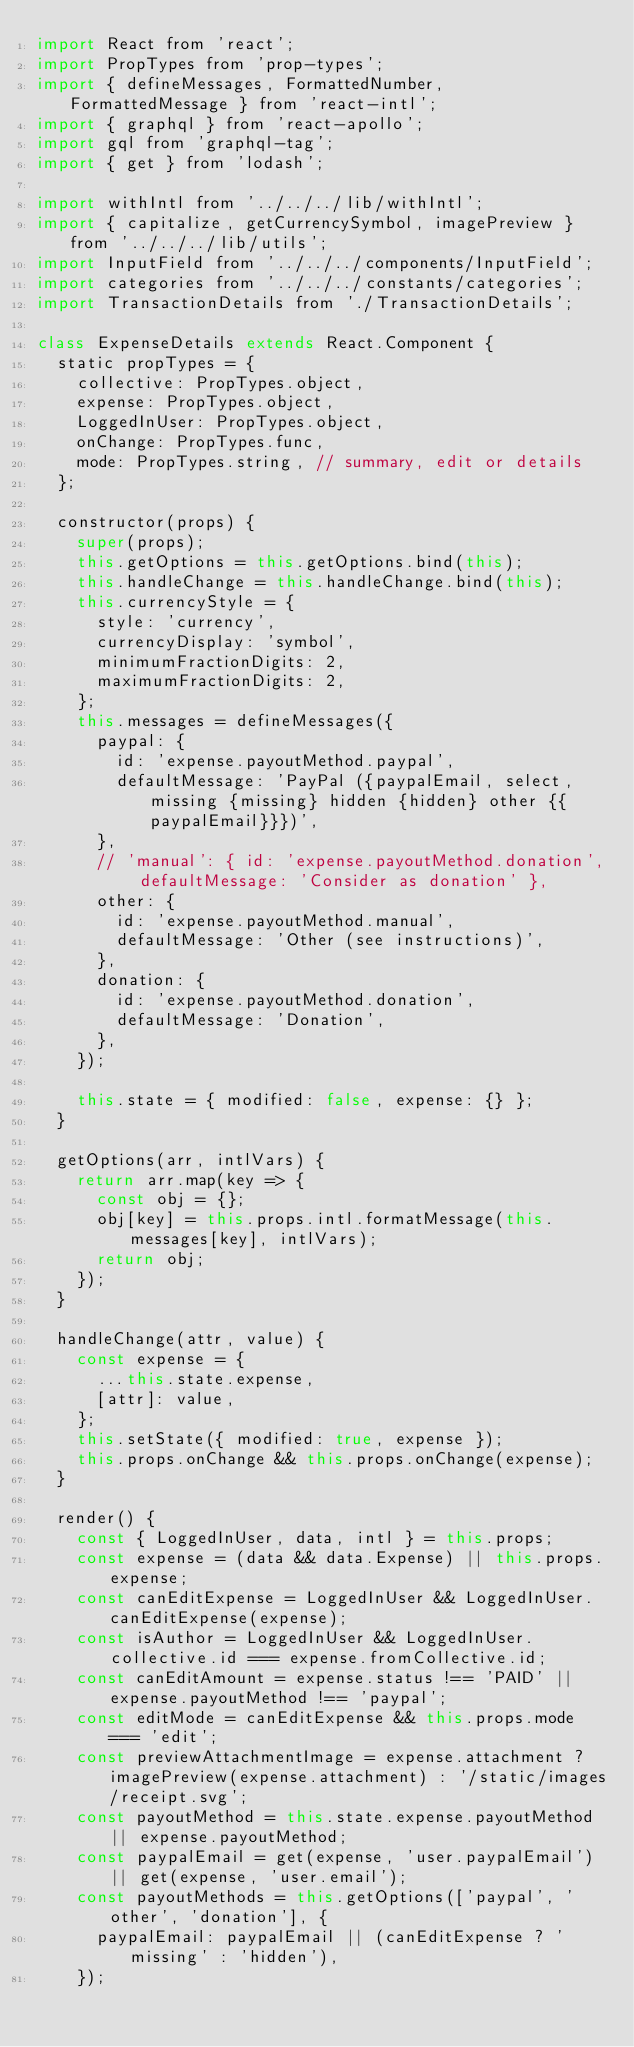<code> <loc_0><loc_0><loc_500><loc_500><_JavaScript_>import React from 'react';
import PropTypes from 'prop-types';
import { defineMessages, FormattedNumber, FormattedMessage } from 'react-intl';
import { graphql } from 'react-apollo';
import gql from 'graphql-tag';
import { get } from 'lodash';

import withIntl from '../../../lib/withIntl';
import { capitalize, getCurrencySymbol, imagePreview } from '../../../lib/utils';
import InputField from '../../../components/InputField';
import categories from '../../../constants/categories';
import TransactionDetails from './TransactionDetails';

class ExpenseDetails extends React.Component {
  static propTypes = {
    collective: PropTypes.object,
    expense: PropTypes.object,
    LoggedInUser: PropTypes.object,
    onChange: PropTypes.func,
    mode: PropTypes.string, // summary, edit or details
  };

  constructor(props) {
    super(props);
    this.getOptions = this.getOptions.bind(this);
    this.handleChange = this.handleChange.bind(this);
    this.currencyStyle = {
      style: 'currency',
      currencyDisplay: 'symbol',
      minimumFractionDigits: 2,
      maximumFractionDigits: 2,
    };
    this.messages = defineMessages({
      paypal: {
        id: 'expense.payoutMethod.paypal',
        defaultMessage: 'PayPal ({paypalEmail, select, missing {missing} hidden {hidden} other {{paypalEmail}}})',
      },
      // 'manual': { id: 'expense.payoutMethod.donation', defaultMessage: 'Consider as donation' },
      other: {
        id: 'expense.payoutMethod.manual',
        defaultMessage: 'Other (see instructions)',
      },
      donation: {
        id: 'expense.payoutMethod.donation',
        defaultMessage: 'Donation',
      },
    });

    this.state = { modified: false, expense: {} };
  }

  getOptions(arr, intlVars) {
    return arr.map(key => {
      const obj = {};
      obj[key] = this.props.intl.formatMessage(this.messages[key], intlVars);
      return obj;
    });
  }

  handleChange(attr, value) {
    const expense = {
      ...this.state.expense,
      [attr]: value,
    };
    this.setState({ modified: true, expense });
    this.props.onChange && this.props.onChange(expense);
  }

  render() {
    const { LoggedInUser, data, intl } = this.props;
    const expense = (data && data.Expense) || this.props.expense;
    const canEditExpense = LoggedInUser && LoggedInUser.canEditExpense(expense);
    const isAuthor = LoggedInUser && LoggedInUser.collective.id === expense.fromCollective.id;
    const canEditAmount = expense.status !== 'PAID' || expense.payoutMethod !== 'paypal';
    const editMode = canEditExpense && this.props.mode === 'edit';
    const previewAttachmentImage = expense.attachment ? imagePreview(expense.attachment) : '/static/images/receipt.svg';
    const payoutMethod = this.state.expense.payoutMethod || expense.payoutMethod;
    const paypalEmail = get(expense, 'user.paypalEmail') || get(expense, 'user.email');
    const payoutMethods = this.getOptions(['paypal', 'other', 'donation'], {
      paypalEmail: paypalEmail || (canEditExpense ? 'missing' : 'hidden'),
    });</code> 